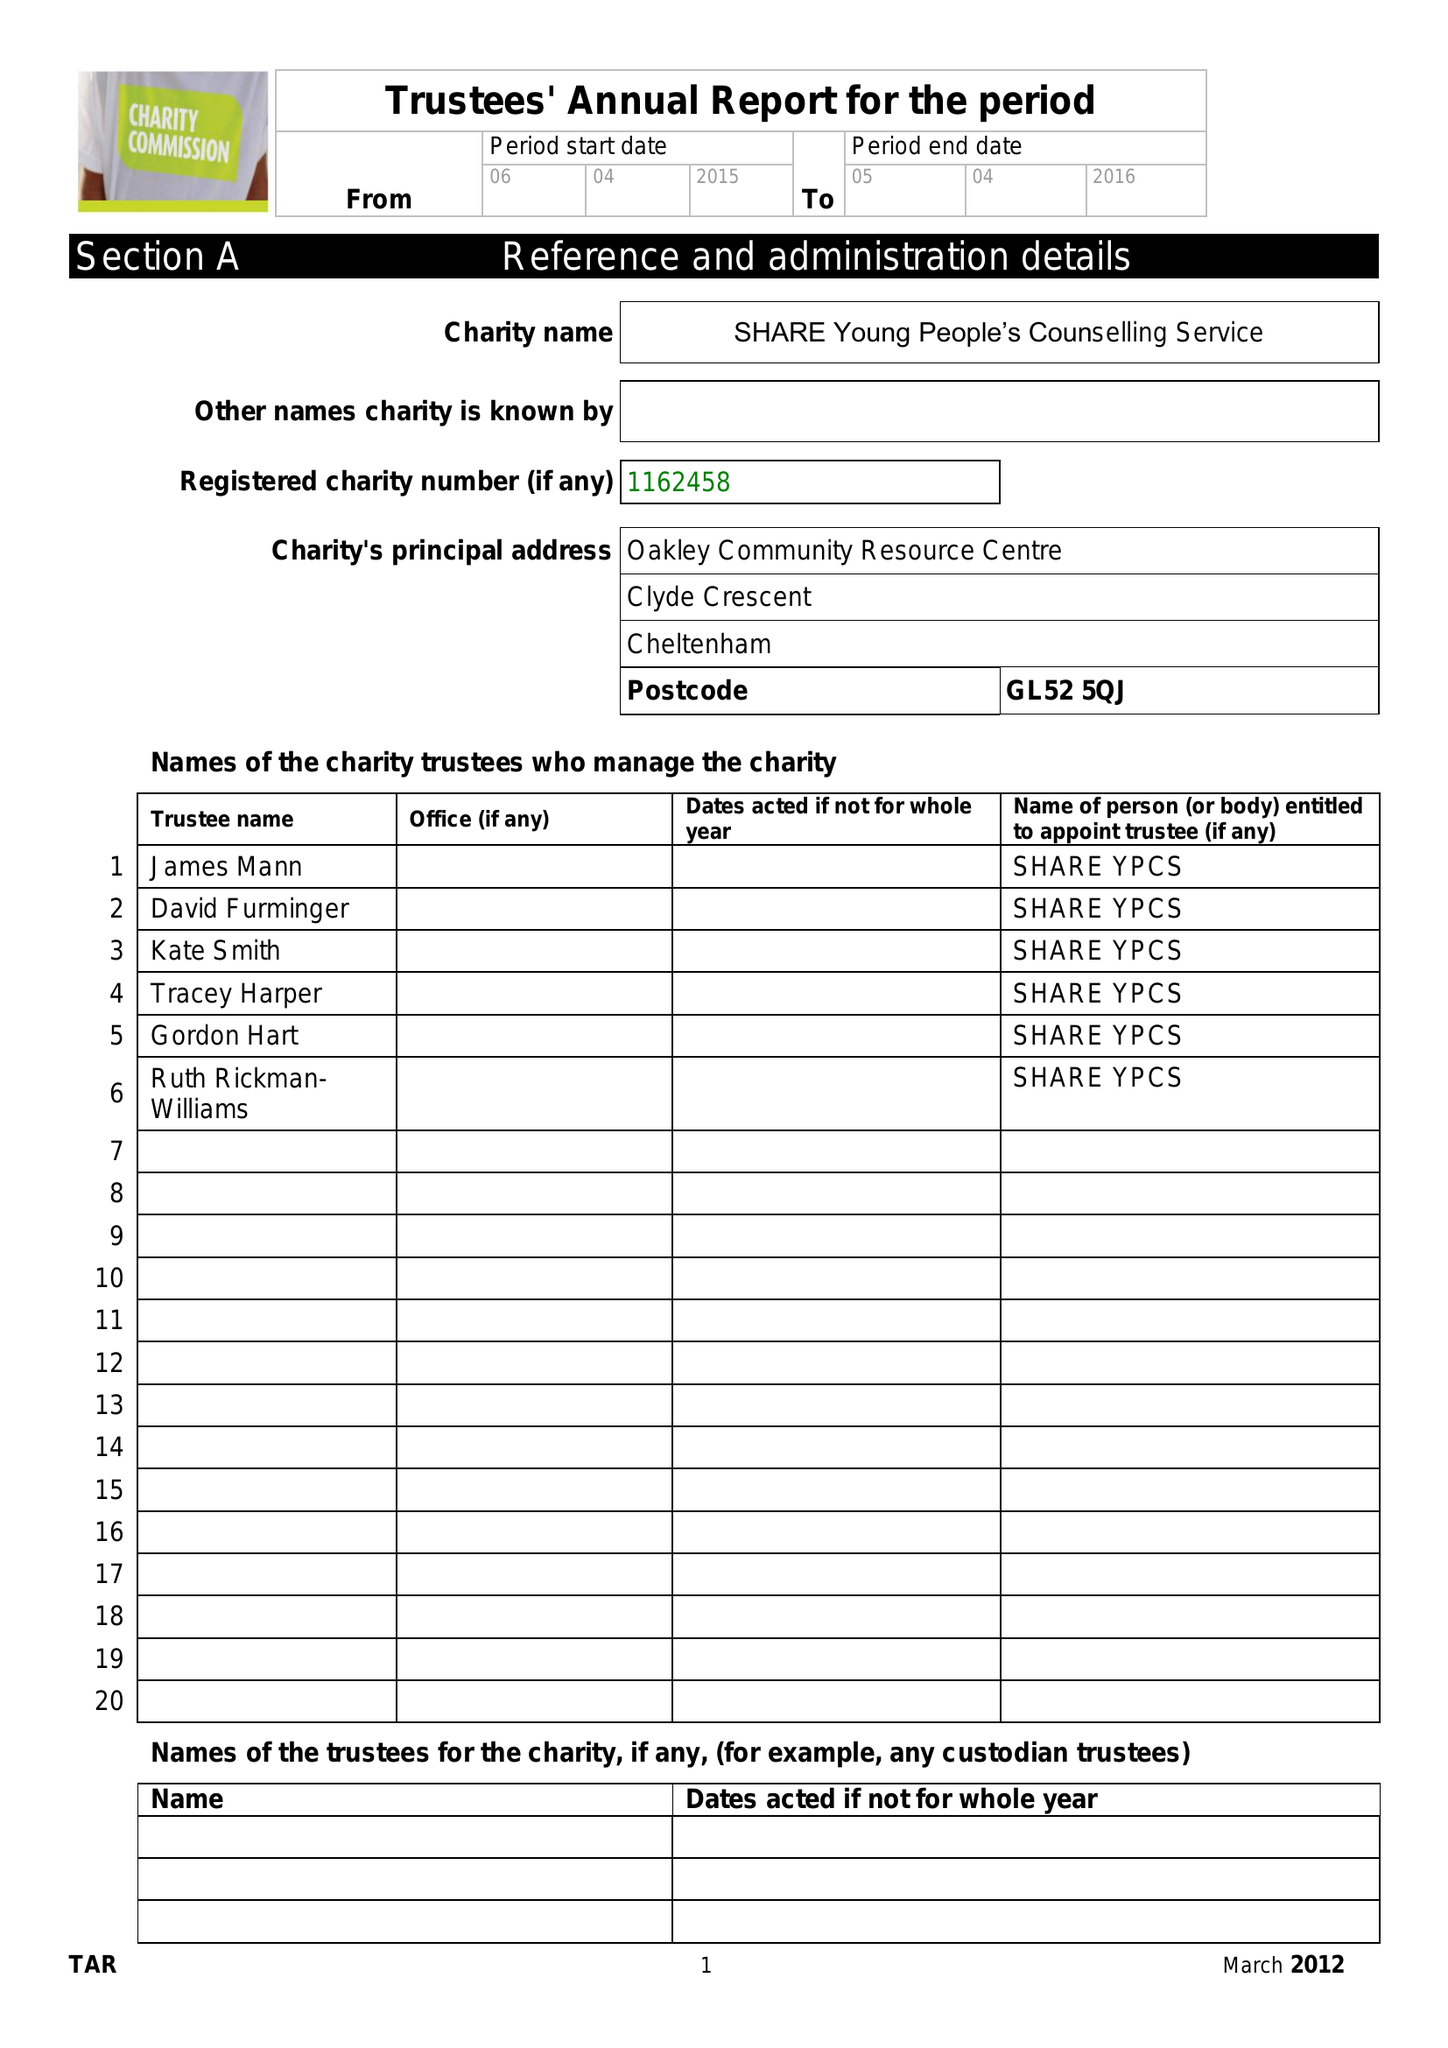What is the value for the income_annually_in_british_pounds?
Answer the question using a single word or phrase. 102.00 